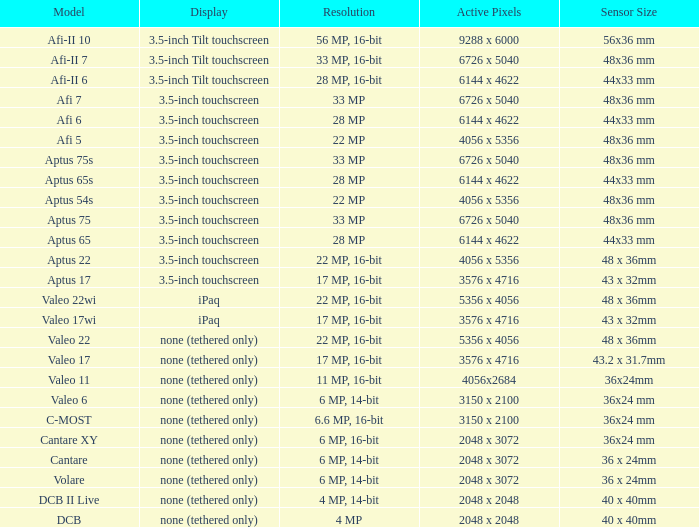Which model has a sensor sized 48x36 mm, pixels of 6726 x 5040, and a 33 mp resolution? Afi 7, Aptus 75s, Aptus 75. 